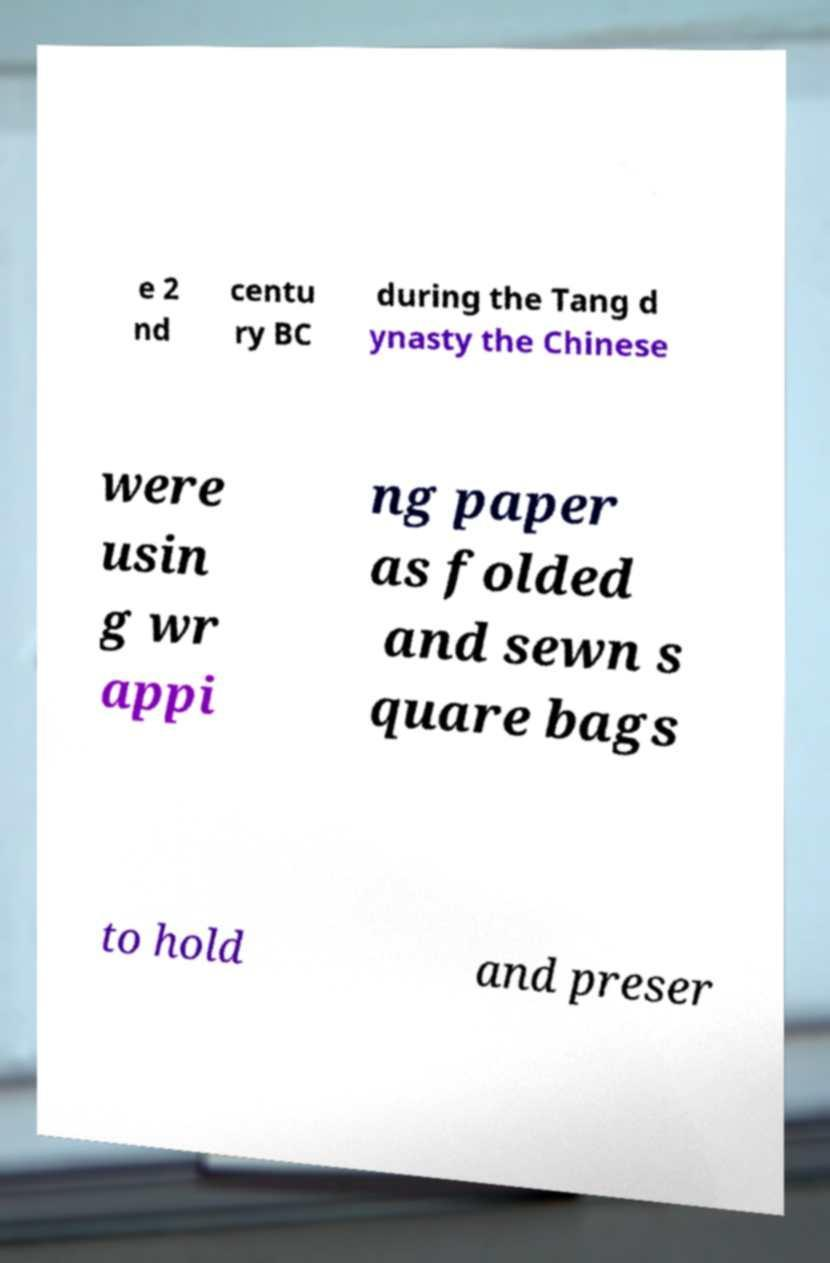For documentation purposes, I need the text within this image transcribed. Could you provide that? e 2 nd centu ry BC during the Tang d ynasty the Chinese were usin g wr appi ng paper as folded and sewn s quare bags to hold and preser 